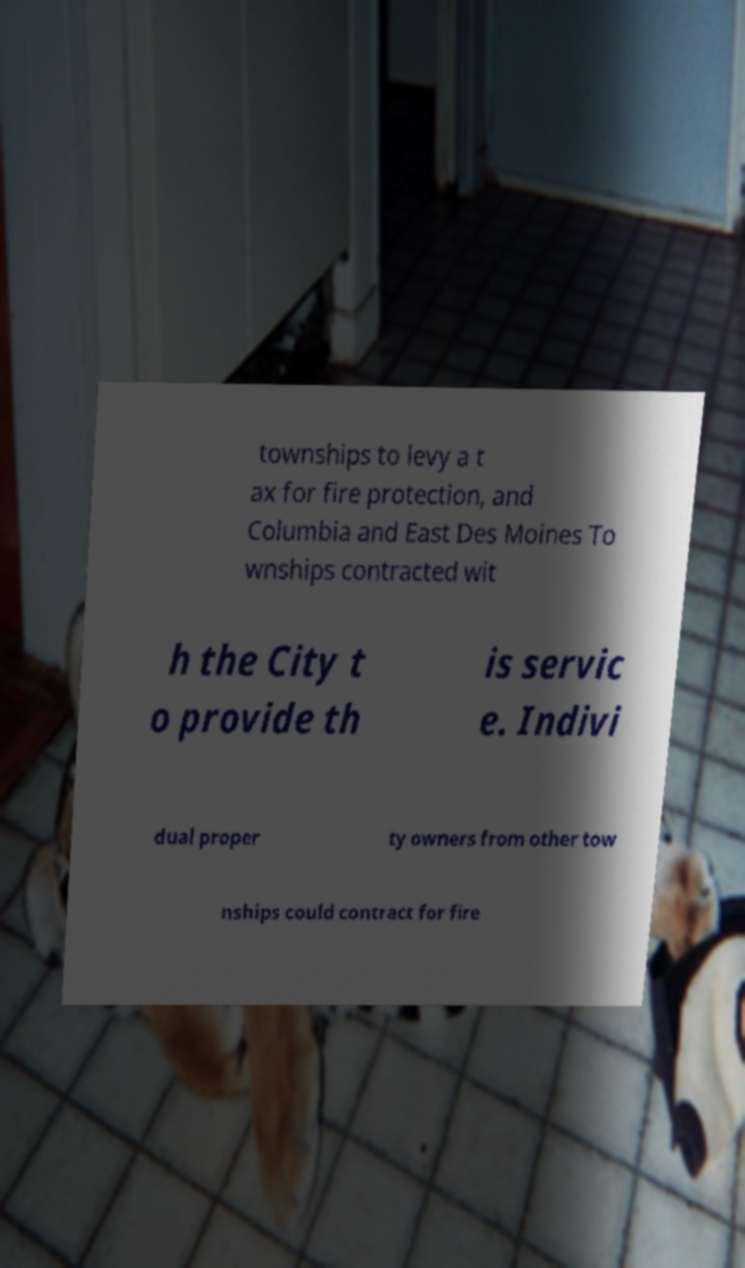Can you accurately transcribe the text from the provided image for me? townships to levy a t ax for fire protection, and Columbia and East Des Moines To wnships contracted wit h the City t o provide th is servic e. Indivi dual proper ty owners from other tow nships could contract for fire 